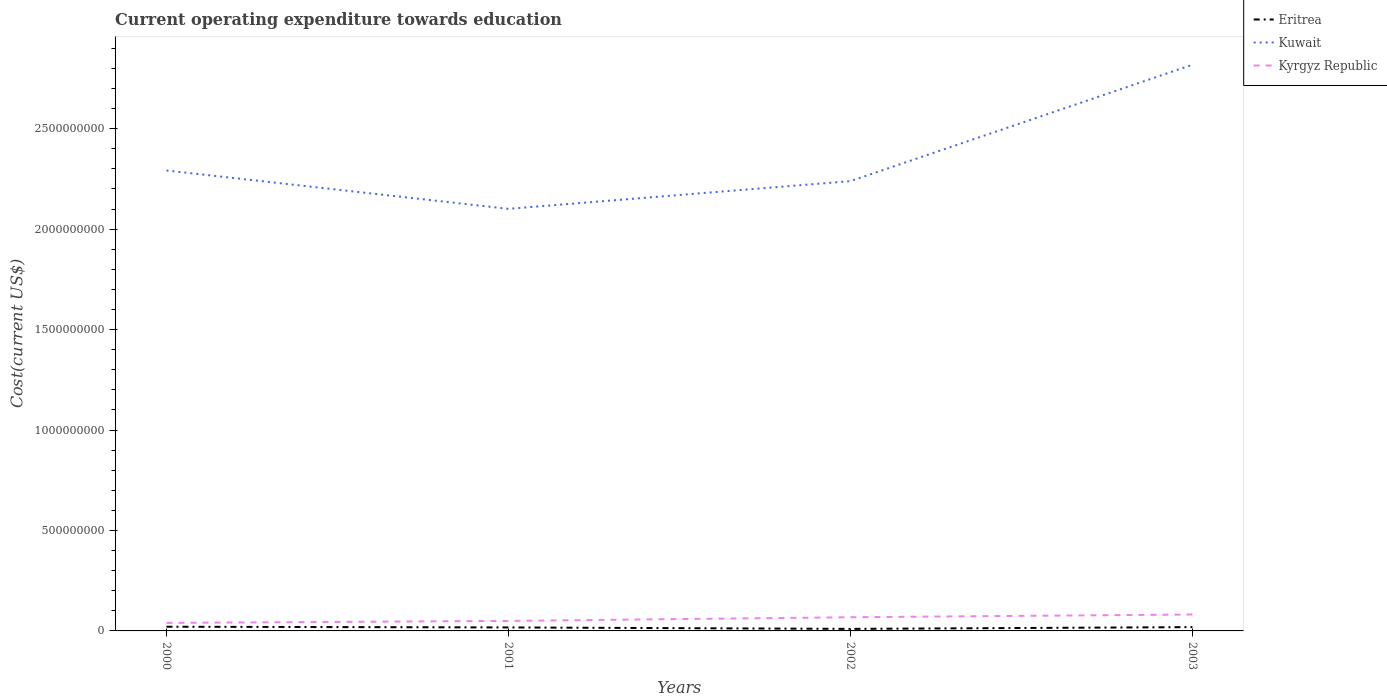Does the line corresponding to Kyrgyz Republic intersect with the line corresponding to Eritrea?
Your answer should be compact. No. Across all years, what is the maximum expenditure towards education in Eritrea?
Provide a short and direct response. 1.02e+07. In which year was the expenditure towards education in Eritrea maximum?
Provide a succinct answer. 2002. What is the total expenditure towards education in Kuwait in the graph?
Your answer should be compact. -5.26e+08. What is the difference between the highest and the second highest expenditure towards education in Kyrgyz Republic?
Make the answer very short. 4.18e+07. Is the expenditure towards education in Kuwait strictly greater than the expenditure towards education in Kyrgyz Republic over the years?
Give a very brief answer. No. How many lines are there?
Ensure brevity in your answer.  3. How many years are there in the graph?
Offer a very short reply. 4. What is the difference between two consecutive major ticks on the Y-axis?
Ensure brevity in your answer.  5.00e+08. Does the graph contain any zero values?
Provide a short and direct response. No. Does the graph contain grids?
Offer a very short reply. No. Where does the legend appear in the graph?
Your answer should be very brief. Top right. How many legend labels are there?
Your answer should be compact. 3. What is the title of the graph?
Offer a terse response. Current operating expenditure towards education. What is the label or title of the Y-axis?
Your answer should be very brief. Cost(current US$). What is the Cost(current US$) in Eritrea in 2000?
Provide a short and direct response. 2.09e+07. What is the Cost(current US$) of Kuwait in 2000?
Offer a terse response. 2.29e+09. What is the Cost(current US$) in Kyrgyz Republic in 2000?
Your answer should be very brief. 3.99e+07. What is the Cost(current US$) of Eritrea in 2001?
Keep it short and to the point. 1.74e+07. What is the Cost(current US$) of Kuwait in 2001?
Make the answer very short. 2.10e+09. What is the Cost(current US$) of Kyrgyz Republic in 2001?
Ensure brevity in your answer.  4.98e+07. What is the Cost(current US$) in Eritrea in 2002?
Offer a terse response. 1.02e+07. What is the Cost(current US$) in Kuwait in 2002?
Your answer should be compact. 2.24e+09. What is the Cost(current US$) of Kyrgyz Republic in 2002?
Your response must be concise. 6.81e+07. What is the Cost(current US$) of Eritrea in 2003?
Provide a short and direct response. 1.89e+07. What is the Cost(current US$) in Kuwait in 2003?
Make the answer very short. 2.82e+09. What is the Cost(current US$) of Kyrgyz Republic in 2003?
Your response must be concise. 8.17e+07. Across all years, what is the maximum Cost(current US$) of Eritrea?
Your response must be concise. 2.09e+07. Across all years, what is the maximum Cost(current US$) of Kuwait?
Give a very brief answer. 2.82e+09. Across all years, what is the maximum Cost(current US$) of Kyrgyz Republic?
Your response must be concise. 8.17e+07. Across all years, what is the minimum Cost(current US$) in Eritrea?
Your answer should be compact. 1.02e+07. Across all years, what is the minimum Cost(current US$) of Kuwait?
Your response must be concise. 2.10e+09. Across all years, what is the minimum Cost(current US$) of Kyrgyz Republic?
Keep it short and to the point. 3.99e+07. What is the total Cost(current US$) in Eritrea in the graph?
Your response must be concise. 6.74e+07. What is the total Cost(current US$) in Kuwait in the graph?
Offer a terse response. 9.45e+09. What is the total Cost(current US$) of Kyrgyz Republic in the graph?
Your answer should be compact. 2.40e+08. What is the difference between the Cost(current US$) of Eritrea in 2000 and that in 2001?
Your answer should be compact. 3.55e+06. What is the difference between the Cost(current US$) of Kuwait in 2000 and that in 2001?
Your response must be concise. 1.91e+08. What is the difference between the Cost(current US$) of Kyrgyz Republic in 2000 and that in 2001?
Keep it short and to the point. -9.93e+06. What is the difference between the Cost(current US$) in Eritrea in 2000 and that in 2002?
Provide a succinct answer. 1.07e+07. What is the difference between the Cost(current US$) in Kuwait in 2000 and that in 2002?
Offer a terse response. 5.30e+07. What is the difference between the Cost(current US$) in Kyrgyz Republic in 2000 and that in 2002?
Provide a succinct answer. -2.82e+07. What is the difference between the Cost(current US$) in Eritrea in 2000 and that in 2003?
Provide a succinct answer. 1.97e+06. What is the difference between the Cost(current US$) of Kuwait in 2000 and that in 2003?
Offer a terse response. -5.26e+08. What is the difference between the Cost(current US$) of Kyrgyz Republic in 2000 and that in 2003?
Keep it short and to the point. -4.18e+07. What is the difference between the Cost(current US$) in Eritrea in 2001 and that in 2002?
Give a very brief answer. 7.18e+06. What is the difference between the Cost(current US$) in Kuwait in 2001 and that in 2002?
Your response must be concise. -1.38e+08. What is the difference between the Cost(current US$) of Kyrgyz Republic in 2001 and that in 2002?
Provide a succinct answer. -1.83e+07. What is the difference between the Cost(current US$) in Eritrea in 2001 and that in 2003?
Keep it short and to the point. -1.58e+06. What is the difference between the Cost(current US$) of Kuwait in 2001 and that in 2003?
Your answer should be very brief. -7.17e+08. What is the difference between the Cost(current US$) of Kyrgyz Republic in 2001 and that in 2003?
Give a very brief answer. -3.19e+07. What is the difference between the Cost(current US$) in Eritrea in 2002 and that in 2003?
Your answer should be very brief. -8.76e+06. What is the difference between the Cost(current US$) of Kuwait in 2002 and that in 2003?
Provide a short and direct response. -5.79e+08. What is the difference between the Cost(current US$) of Kyrgyz Republic in 2002 and that in 2003?
Make the answer very short. -1.36e+07. What is the difference between the Cost(current US$) in Eritrea in 2000 and the Cost(current US$) in Kuwait in 2001?
Provide a short and direct response. -2.08e+09. What is the difference between the Cost(current US$) in Eritrea in 2000 and the Cost(current US$) in Kyrgyz Republic in 2001?
Offer a very short reply. -2.89e+07. What is the difference between the Cost(current US$) in Kuwait in 2000 and the Cost(current US$) in Kyrgyz Republic in 2001?
Give a very brief answer. 2.24e+09. What is the difference between the Cost(current US$) of Eritrea in 2000 and the Cost(current US$) of Kuwait in 2002?
Offer a very short reply. -2.22e+09. What is the difference between the Cost(current US$) in Eritrea in 2000 and the Cost(current US$) in Kyrgyz Republic in 2002?
Keep it short and to the point. -4.72e+07. What is the difference between the Cost(current US$) of Kuwait in 2000 and the Cost(current US$) of Kyrgyz Republic in 2002?
Ensure brevity in your answer.  2.22e+09. What is the difference between the Cost(current US$) of Eritrea in 2000 and the Cost(current US$) of Kuwait in 2003?
Your answer should be very brief. -2.80e+09. What is the difference between the Cost(current US$) in Eritrea in 2000 and the Cost(current US$) in Kyrgyz Republic in 2003?
Give a very brief answer. -6.08e+07. What is the difference between the Cost(current US$) of Kuwait in 2000 and the Cost(current US$) of Kyrgyz Republic in 2003?
Keep it short and to the point. 2.21e+09. What is the difference between the Cost(current US$) in Eritrea in 2001 and the Cost(current US$) in Kuwait in 2002?
Your answer should be compact. -2.22e+09. What is the difference between the Cost(current US$) in Eritrea in 2001 and the Cost(current US$) in Kyrgyz Republic in 2002?
Provide a short and direct response. -5.08e+07. What is the difference between the Cost(current US$) in Kuwait in 2001 and the Cost(current US$) in Kyrgyz Republic in 2002?
Provide a short and direct response. 2.03e+09. What is the difference between the Cost(current US$) of Eritrea in 2001 and the Cost(current US$) of Kuwait in 2003?
Offer a very short reply. -2.80e+09. What is the difference between the Cost(current US$) of Eritrea in 2001 and the Cost(current US$) of Kyrgyz Republic in 2003?
Your answer should be compact. -6.44e+07. What is the difference between the Cost(current US$) of Kuwait in 2001 and the Cost(current US$) of Kyrgyz Republic in 2003?
Your answer should be compact. 2.02e+09. What is the difference between the Cost(current US$) of Eritrea in 2002 and the Cost(current US$) of Kuwait in 2003?
Ensure brevity in your answer.  -2.81e+09. What is the difference between the Cost(current US$) in Eritrea in 2002 and the Cost(current US$) in Kyrgyz Republic in 2003?
Offer a terse response. -7.15e+07. What is the difference between the Cost(current US$) in Kuwait in 2002 and the Cost(current US$) in Kyrgyz Republic in 2003?
Provide a short and direct response. 2.16e+09. What is the average Cost(current US$) in Eritrea per year?
Your answer should be very brief. 1.68e+07. What is the average Cost(current US$) in Kuwait per year?
Make the answer very short. 2.36e+09. What is the average Cost(current US$) of Kyrgyz Republic per year?
Your answer should be compact. 5.99e+07. In the year 2000, what is the difference between the Cost(current US$) in Eritrea and Cost(current US$) in Kuwait?
Provide a short and direct response. -2.27e+09. In the year 2000, what is the difference between the Cost(current US$) in Eritrea and Cost(current US$) in Kyrgyz Republic?
Provide a succinct answer. -1.90e+07. In the year 2000, what is the difference between the Cost(current US$) in Kuwait and Cost(current US$) in Kyrgyz Republic?
Provide a short and direct response. 2.25e+09. In the year 2001, what is the difference between the Cost(current US$) of Eritrea and Cost(current US$) of Kuwait?
Make the answer very short. -2.08e+09. In the year 2001, what is the difference between the Cost(current US$) in Eritrea and Cost(current US$) in Kyrgyz Republic?
Provide a succinct answer. -3.25e+07. In the year 2001, what is the difference between the Cost(current US$) of Kuwait and Cost(current US$) of Kyrgyz Republic?
Ensure brevity in your answer.  2.05e+09. In the year 2002, what is the difference between the Cost(current US$) of Eritrea and Cost(current US$) of Kuwait?
Your answer should be very brief. -2.23e+09. In the year 2002, what is the difference between the Cost(current US$) of Eritrea and Cost(current US$) of Kyrgyz Republic?
Your response must be concise. -5.79e+07. In the year 2002, what is the difference between the Cost(current US$) of Kuwait and Cost(current US$) of Kyrgyz Republic?
Provide a short and direct response. 2.17e+09. In the year 2003, what is the difference between the Cost(current US$) of Eritrea and Cost(current US$) of Kuwait?
Make the answer very short. -2.80e+09. In the year 2003, what is the difference between the Cost(current US$) in Eritrea and Cost(current US$) in Kyrgyz Republic?
Provide a succinct answer. -6.28e+07. In the year 2003, what is the difference between the Cost(current US$) of Kuwait and Cost(current US$) of Kyrgyz Republic?
Offer a very short reply. 2.74e+09. What is the ratio of the Cost(current US$) of Eritrea in 2000 to that in 2001?
Provide a short and direct response. 1.2. What is the ratio of the Cost(current US$) of Kuwait in 2000 to that in 2001?
Your answer should be very brief. 1.09. What is the ratio of the Cost(current US$) of Kyrgyz Republic in 2000 to that in 2001?
Provide a short and direct response. 0.8. What is the ratio of the Cost(current US$) of Eritrea in 2000 to that in 2002?
Offer a terse response. 2.05. What is the ratio of the Cost(current US$) of Kuwait in 2000 to that in 2002?
Make the answer very short. 1.02. What is the ratio of the Cost(current US$) of Kyrgyz Republic in 2000 to that in 2002?
Your answer should be very brief. 0.59. What is the ratio of the Cost(current US$) of Eritrea in 2000 to that in 2003?
Your response must be concise. 1.1. What is the ratio of the Cost(current US$) of Kuwait in 2000 to that in 2003?
Offer a terse response. 0.81. What is the ratio of the Cost(current US$) of Kyrgyz Republic in 2000 to that in 2003?
Your answer should be compact. 0.49. What is the ratio of the Cost(current US$) of Eritrea in 2001 to that in 2002?
Provide a succinct answer. 1.71. What is the ratio of the Cost(current US$) in Kuwait in 2001 to that in 2002?
Make the answer very short. 0.94. What is the ratio of the Cost(current US$) in Kyrgyz Republic in 2001 to that in 2002?
Provide a succinct answer. 0.73. What is the ratio of the Cost(current US$) of Eritrea in 2001 to that in 2003?
Your response must be concise. 0.92. What is the ratio of the Cost(current US$) of Kuwait in 2001 to that in 2003?
Your answer should be compact. 0.75. What is the ratio of the Cost(current US$) in Kyrgyz Republic in 2001 to that in 2003?
Provide a succinct answer. 0.61. What is the ratio of the Cost(current US$) in Eritrea in 2002 to that in 2003?
Give a very brief answer. 0.54. What is the ratio of the Cost(current US$) in Kuwait in 2002 to that in 2003?
Keep it short and to the point. 0.79. What is the ratio of the Cost(current US$) of Kyrgyz Republic in 2002 to that in 2003?
Offer a terse response. 0.83. What is the difference between the highest and the second highest Cost(current US$) of Eritrea?
Provide a short and direct response. 1.97e+06. What is the difference between the highest and the second highest Cost(current US$) of Kuwait?
Ensure brevity in your answer.  5.26e+08. What is the difference between the highest and the second highest Cost(current US$) in Kyrgyz Republic?
Keep it short and to the point. 1.36e+07. What is the difference between the highest and the lowest Cost(current US$) in Eritrea?
Your answer should be compact. 1.07e+07. What is the difference between the highest and the lowest Cost(current US$) in Kuwait?
Provide a short and direct response. 7.17e+08. What is the difference between the highest and the lowest Cost(current US$) in Kyrgyz Republic?
Offer a very short reply. 4.18e+07. 